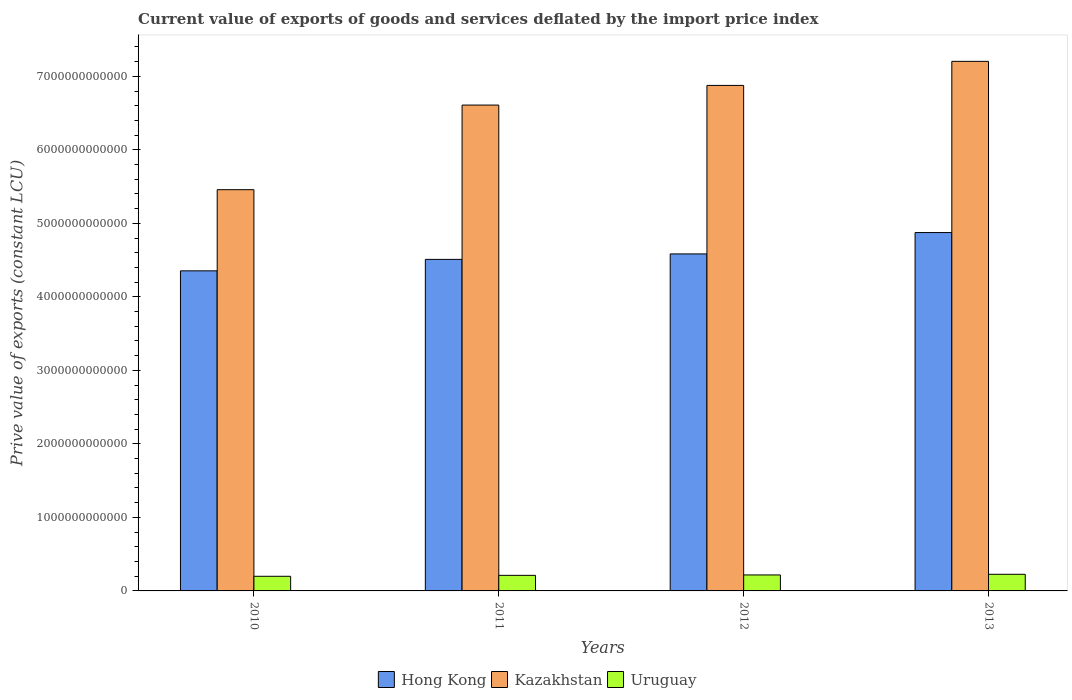What is the prive value of exports in Kazakhstan in 2010?
Give a very brief answer. 5.46e+12. Across all years, what is the maximum prive value of exports in Uruguay?
Make the answer very short. 2.26e+11. Across all years, what is the minimum prive value of exports in Hong Kong?
Give a very brief answer. 4.35e+12. In which year was the prive value of exports in Uruguay minimum?
Your answer should be compact. 2010. What is the total prive value of exports in Hong Kong in the graph?
Give a very brief answer. 1.83e+13. What is the difference between the prive value of exports in Uruguay in 2011 and that in 2013?
Offer a terse response. -1.45e+1. What is the difference between the prive value of exports in Kazakhstan in 2011 and the prive value of exports in Uruguay in 2012?
Your answer should be compact. 6.39e+12. What is the average prive value of exports in Kazakhstan per year?
Give a very brief answer. 6.54e+12. In the year 2013, what is the difference between the prive value of exports in Kazakhstan and prive value of exports in Hong Kong?
Your answer should be compact. 2.33e+12. What is the ratio of the prive value of exports in Uruguay in 2010 to that in 2012?
Offer a terse response. 0.92. Is the prive value of exports in Hong Kong in 2010 less than that in 2013?
Make the answer very short. Yes. Is the difference between the prive value of exports in Kazakhstan in 2011 and 2012 greater than the difference between the prive value of exports in Hong Kong in 2011 and 2012?
Provide a succinct answer. No. What is the difference between the highest and the second highest prive value of exports in Hong Kong?
Offer a very short reply. 2.91e+11. What is the difference between the highest and the lowest prive value of exports in Kazakhstan?
Offer a terse response. 1.75e+12. In how many years, is the prive value of exports in Kazakhstan greater than the average prive value of exports in Kazakhstan taken over all years?
Ensure brevity in your answer.  3. What does the 1st bar from the left in 2013 represents?
Ensure brevity in your answer.  Hong Kong. What does the 3rd bar from the right in 2011 represents?
Offer a very short reply. Hong Kong. How many bars are there?
Your answer should be compact. 12. What is the difference between two consecutive major ticks on the Y-axis?
Your response must be concise. 1.00e+12. Does the graph contain grids?
Give a very brief answer. No. What is the title of the graph?
Your answer should be compact. Current value of exports of goods and services deflated by the import price index. Does "High income" appear as one of the legend labels in the graph?
Keep it short and to the point. No. What is the label or title of the X-axis?
Offer a very short reply. Years. What is the label or title of the Y-axis?
Give a very brief answer. Prive value of exports (constant LCU). What is the Prive value of exports (constant LCU) of Hong Kong in 2010?
Your answer should be very brief. 4.35e+12. What is the Prive value of exports (constant LCU) in Kazakhstan in 2010?
Give a very brief answer. 5.46e+12. What is the Prive value of exports (constant LCU) of Uruguay in 2010?
Ensure brevity in your answer.  1.99e+11. What is the Prive value of exports (constant LCU) in Hong Kong in 2011?
Offer a very short reply. 4.51e+12. What is the Prive value of exports (constant LCU) in Kazakhstan in 2011?
Provide a short and direct response. 6.61e+12. What is the Prive value of exports (constant LCU) in Uruguay in 2011?
Provide a short and direct response. 2.12e+11. What is the Prive value of exports (constant LCU) in Hong Kong in 2012?
Keep it short and to the point. 4.58e+12. What is the Prive value of exports (constant LCU) in Kazakhstan in 2012?
Ensure brevity in your answer.  6.88e+12. What is the Prive value of exports (constant LCU) of Uruguay in 2012?
Give a very brief answer. 2.17e+11. What is the Prive value of exports (constant LCU) in Hong Kong in 2013?
Provide a short and direct response. 4.87e+12. What is the Prive value of exports (constant LCU) of Kazakhstan in 2013?
Keep it short and to the point. 7.20e+12. What is the Prive value of exports (constant LCU) of Uruguay in 2013?
Your response must be concise. 2.26e+11. Across all years, what is the maximum Prive value of exports (constant LCU) in Hong Kong?
Your answer should be compact. 4.87e+12. Across all years, what is the maximum Prive value of exports (constant LCU) of Kazakhstan?
Your response must be concise. 7.20e+12. Across all years, what is the maximum Prive value of exports (constant LCU) in Uruguay?
Make the answer very short. 2.26e+11. Across all years, what is the minimum Prive value of exports (constant LCU) of Hong Kong?
Your answer should be very brief. 4.35e+12. Across all years, what is the minimum Prive value of exports (constant LCU) in Kazakhstan?
Provide a short and direct response. 5.46e+12. Across all years, what is the minimum Prive value of exports (constant LCU) of Uruguay?
Offer a very short reply. 1.99e+11. What is the total Prive value of exports (constant LCU) of Hong Kong in the graph?
Keep it short and to the point. 1.83e+13. What is the total Prive value of exports (constant LCU) in Kazakhstan in the graph?
Your response must be concise. 2.61e+13. What is the total Prive value of exports (constant LCU) of Uruguay in the graph?
Offer a terse response. 8.54e+11. What is the difference between the Prive value of exports (constant LCU) in Hong Kong in 2010 and that in 2011?
Ensure brevity in your answer.  -1.56e+11. What is the difference between the Prive value of exports (constant LCU) of Kazakhstan in 2010 and that in 2011?
Keep it short and to the point. -1.15e+12. What is the difference between the Prive value of exports (constant LCU) in Uruguay in 2010 and that in 2011?
Your answer should be very brief. -1.29e+1. What is the difference between the Prive value of exports (constant LCU) of Hong Kong in 2010 and that in 2012?
Provide a succinct answer. -2.30e+11. What is the difference between the Prive value of exports (constant LCU) of Kazakhstan in 2010 and that in 2012?
Keep it short and to the point. -1.42e+12. What is the difference between the Prive value of exports (constant LCU) of Uruguay in 2010 and that in 2012?
Your response must be concise. -1.84e+1. What is the difference between the Prive value of exports (constant LCU) in Hong Kong in 2010 and that in 2013?
Make the answer very short. -5.21e+11. What is the difference between the Prive value of exports (constant LCU) of Kazakhstan in 2010 and that in 2013?
Offer a very short reply. -1.75e+12. What is the difference between the Prive value of exports (constant LCU) of Uruguay in 2010 and that in 2013?
Your response must be concise. -2.74e+1. What is the difference between the Prive value of exports (constant LCU) in Hong Kong in 2011 and that in 2012?
Your response must be concise. -7.45e+1. What is the difference between the Prive value of exports (constant LCU) in Kazakhstan in 2011 and that in 2012?
Provide a succinct answer. -2.67e+11. What is the difference between the Prive value of exports (constant LCU) in Uruguay in 2011 and that in 2012?
Provide a succinct answer. -5.47e+09. What is the difference between the Prive value of exports (constant LCU) in Hong Kong in 2011 and that in 2013?
Make the answer very short. -3.65e+11. What is the difference between the Prive value of exports (constant LCU) of Kazakhstan in 2011 and that in 2013?
Your answer should be compact. -5.95e+11. What is the difference between the Prive value of exports (constant LCU) in Uruguay in 2011 and that in 2013?
Offer a very short reply. -1.45e+1. What is the difference between the Prive value of exports (constant LCU) in Hong Kong in 2012 and that in 2013?
Offer a very short reply. -2.91e+11. What is the difference between the Prive value of exports (constant LCU) in Kazakhstan in 2012 and that in 2013?
Your answer should be very brief. -3.27e+11. What is the difference between the Prive value of exports (constant LCU) in Uruguay in 2012 and that in 2013?
Your answer should be very brief. -9.01e+09. What is the difference between the Prive value of exports (constant LCU) of Hong Kong in 2010 and the Prive value of exports (constant LCU) of Kazakhstan in 2011?
Keep it short and to the point. -2.25e+12. What is the difference between the Prive value of exports (constant LCU) in Hong Kong in 2010 and the Prive value of exports (constant LCU) in Uruguay in 2011?
Give a very brief answer. 4.14e+12. What is the difference between the Prive value of exports (constant LCU) in Kazakhstan in 2010 and the Prive value of exports (constant LCU) in Uruguay in 2011?
Give a very brief answer. 5.25e+12. What is the difference between the Prive value of exports (constant LCU) of Hong Kong in 2010 and the Prive value of exports (constant LCU) of Kazakhstan in 2012?
Your response must be concise. -2.52e+12. What is the difference between the Prive value of exports (constant LCU) in Hong Kong in 2010 and the Prive value of exports (constant LCU) in Uruguay in 2012?
Provide a succinct answer. 4.14e+12. What is the difference between the Prive value of exports (constant LCU) of Kazakhstan in 2010 and the Prive value of exports (constant LCU) of Uruguay in 2012?
Your answer should be very brief. 5.24e+12. What is the difference between the Prive value of exports (constant LCU) of Hong Kong in 2010 and the Prive value of exports (constant LCU) of Kazakhstan in 2013?
Give a very brief answer. -2.85e+12. What is the difference between the Prive value of exports (constant LCU) in Hong Kong in 2010 and the Prive value of exports (constant LCU) in Uruguay in 2013?
Provide a succinct answer. 4.13e+12. What is the difference between the Prive value of exports (constant LCU) in Kazakhstan in 2010 and the Prive value of exports (constant LCU) in Uruguay in 2013?
Provide a short and direct response. 5.23e+12. What is the difference between the Prive value of exports (constant LCU) of Hong Kong in 2011 and the Prive value of exports (constant LCU) of Kazakhstan in 2012?
Your answer should be compact. -2.37e+12. What is the difference between the Prive value of exports (constant LCU) of Hong Kong in 2011 and the Prive value of exports (constant LCU) of Uruguay in 2012?
Your answer should be very brief. 4.29e+12. What is the difference between the Prive value of exports (constant LCU) of Kazakhstan in 2011 and the Prive value of exports (constant LCU) of Uruguay in 2012?
Ensure brevity in your answer.  6.39e+12. What is the difference between the Prive value of exports (constant LCU) in Hong Kong in 2011 and the Prive value of exports (constant LCU) in Kazakhstan in 2013?
Keep it short and to the point. -2.69e+12. What is the difference between the Prive value of exports (constant LCU) of Hong Kong in 2011 and the Prive value of exports (constant LCU) of Uruguay in 2013?
Provide a short and direct response. 4.28e+12. What is the difference between the Prive value of exports (constant LCU) in Kazakhstan in 2011 and the Prive value of exports (constant LCU) in Uruguay in 2013?
Make the answer very short. 6.38e+12. What is the difference between the Prive value of exports (constant LCU) of Hong Kong in 2012 and the Prive value of exports (constant LCU) of Kazakhstan in 2013?
Give a very brief answer. -2.62e+12. What is the difference between the Prive value of exports (constant LCU) in Hong Kong in 2012 and the Prive value of exports (constant LCU) in Uruguay in 2013?
Your answer should be very brief. 4.36e+12. What is the difference between the Prive value of exports (constant LCU) in Kazakhstan in 2012 and the Prive value of exports (constant LCU) in Uruguay in 2013?
Provide a short and direct response. 6.65e+12. What is the average Prive value of exports (constant LCU) in Hong Kong per year?
Give a very brief answer. 4.58e+12. What is the average Prive value of exports (constant LCU) of Kazakhstan per year?
Offer a very short reply. 6.54e+12. What is the average Prive value of exports (constant LCU) of Uruguay per year?
Make the answer very short. 2.14e+11. In the year 2010, what is the difference between the Prive value of exports (constant LCU) of Hong Kong and Prive value of exports (constant LCU) of Kazakhstan?
Your response must be concise. -1.10e+12. In the year 2010, what is the difference between the Prive value of exports (constant LCU) in Hong Kong and Prive value of exports (constant LCU) in Uruguay?
Ensure brevity in your answer.  4.15e+12. In the year 2010, what is the difference between the Prive value of exports (constant LCU) of Kazakhstan and Prive value of exports (constant LCU) of Uruguay?
Your response must be concise. 5.26e+12. In the year 2011, what is the difference between the Prive value of exports (constant LCU) in Hong Kong and Prive value of exports (constant LCU) in Kazakhstan?
Offer a terse response. -2.10e+12. In the year 2011, what is the difference between the Prive value of exports (constant LCU) of Hong Kong and Prive value of exports (constant LCU) of Uruguay?
Offer a very short reply. 4.30e+12. In the year 2011, what is the difference between the Prive value of exports (constant LCU) of Kazakhstan and Prive value of exports (constant LCU) of Uruguay?
Offer a very short reply. 6.40e+12. In the year 2012, what is the difference between the Prive value of exports (constant LCU) of Hong Kong and Prive value of exports (constant LCU) of Kazakhstan?
Your response must be concise. -2.29e+12. In the year 2012, what is the difference between the Prive value of exports (constant LCU) in Hong Kong and Prive value of exports (constant LCU) in Uruguay?
Your answer should be compact. 4.37e+12. In the year 2012, what is the difference between the Prive value of exports (constant LCU) in Kazakhstan and Prive value of exports (constant LCU) in Uruguay?
Make the answer very short. 6.66e+12. In the year 2013, what is the difference between the Prive value of exports (constant LCU) of Hong Kong and Prive value of exports (constant LCU) of Kazakhstan?
Offer a terse response. -2.33e+12. In the year 2013, what is the difference between the Prive value of exports (constant LCU) of Hong Kong and Prive value of exports (constant LCU) of Uruguay?
Your answer should be very brief. 4.65e+12. In the year 2013, what is the difference between the Prive value of exports (constant LCU) in Kazakhstan and Prive value of exports (constant LCU) in Uruguay?
Keep it short and to the point. 6.98e+12. What is the ratio of the Prive value of exports (constant LCU) in Hong Kong in 2010 to that in 2011?
Offer a terse response. 0.97. What is the ratio of the Prive value of exports (constant LCU) in Kazakhstan in 2010 to that in 2011?
Give a very brief answer. 0.83. What is the ratio of the Prive value of exports (constant LCU) of Uruguay in 2010 to that in 2011?
Your response must be concise. 0.94. What is the ratio of the Prive value of exports (constant LCU) of Hong Kong in 2010 to that in 2012?
Ensure brevity in your answer.  0.95. What is the ratio of the Prive value of exports (constant LCU) in Kazakhstan in 2010 to that in 2012?
Provide a short and direct response. 0.79. What is the ratio of the Prive value of exports (constant LCU) in Uruguay in 2010 to that in 2012?
Offer a very short reply. 0.92. What is the ratio of the Prive value of exports (constant LCU) in Hong Kong in 2010 to that in 2013?
Offer a terse response. 0.89. What is the ratio of the Prive value of exports (constant LCU) of Kazakhstan in 2010 to that in 2013?
Ensure brevity in your answer.  0.76. What is the ratio of the Prive value of exports (constant LCU) in Uruguay in 2010 to that in 2013?
Make the answer very short. 0.88. What is the ratio of the Prive value of exports (constant LCU) of Hong Kong in 2011 to that in 2012?
Offer a very short reply. 0.98. What is the ratio of the Prive value of exports (constant LCU) in Kazakhstan in 2011 to that in 2012?
Ensure brevity in your answer.  0.96. What is the ratio of the Prive value of exports (constant LCU) of Uruguay in 2011 to that in 2012?
Provide a short and direct response. 0.97. What is the ratio of the Prive value of exports (constant LCU) in Hong Kong in 2011 to that in 2013?
Offer a terse response. 0.93. What is the ratio of the Prive value of exports (constant LCU) in Kazakhstan in 2011 to that in 2013?
Your response must be concise. 0.92. What is the ratio of the Prive value of exports (constant LCU) of Uruguay in 2011 to that in 2013?
Ensure brevity in your answer.  0.94. What is the ratio of the Prive value of exports (constant LCU) of Hong Kong in 2012 to that in 2013?
Give a very brief answer. 0.94. What is the ratio of the Prive value of exports (constant LCU) of Kazakhstan in 2012 to that in 2013?
Ensure brevity in your answer.  0.95. What is the ratio of the Prive value of exports (constant LCU) of Uruguay in 2012 to that in 2013?
Give a very brief answer. 0.96. What is the difference between the highest and the second highest Prive value of exports (constant LCU) of Hong Kong?
Ensure brevity in your answer.  2.91e+11. What is the difference between the highest and the second highest Prive value of exports (constant LCU) of Kazakhstan?
Ensure brevity in your answer.  3.27e+11. What is the difference between the highest and the second highest Prive value of exports (constant LCU) in Uruguay?
Offer a terse response. 9.01e+09. What is the difference between the highest and the lowest Prive value of exports (constant LCU) of Hong Kong?
Give a very brief answer. 5.21e+11. What is the difference between the highest and the lowest Prive value of exports (constant LCU) of Kazakhstan?
Provide a short and direct response. 1.75e+12. What is the difference between the highest and the lowest Prive value of exports (constant LCU) in Uruguay?
Give a very brief answer. 2.74e+1. 